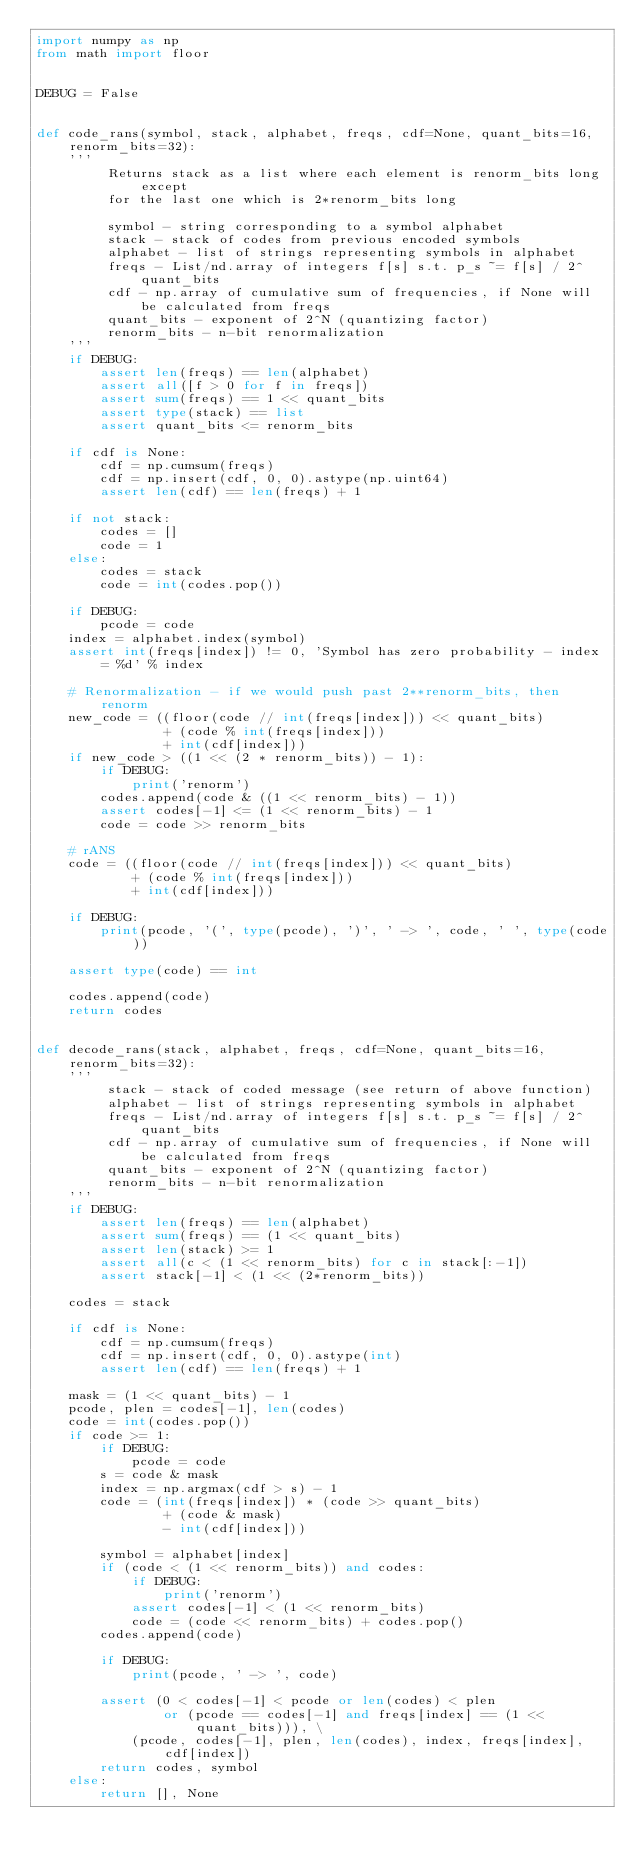<code> <loc_0><loc_0><loc_500><loc_500><_Python_>import numpy as np
from math import floor


DEBUG = False


def code_rans(symbol, stack, alphabet, freqs, cdf=None, quant_bits=16, renorm_bits=32):
    '''
         Returns stack as a list where each element is renorm_bits long except
         for the last one which is 2*renorm_bits long

         symbol - string corresponding to a symbol alphabet
         stack - stack of codes from previous encoded symbols
         alphabet - list of strings representing symbols in alphabet
         freqs - List/nd.array of integers f[s] s.t. p_s ~= f[s] / 2^quant_bits
         cdf - np.array of cumulative sum of frequencies, if None will be calculated from freqs
         quant_bits - exponent of 2^N (quantizing factor)
         renorm_bits - n-bit renormalization
    '''
    if DEBUG:
        assert len(freqs) == len(alphabet)
        assert all([f > 0 for f in freqs])
        assert sum(freqs) == 1 << quant_bits
        assert type(stack) == list
        assert quant_bits <= renorm_bits

    if cdf is None:
        cdf = np.cumsum(freqs)
        cdf = np.insert(cdf, 0, 0).astype(np.uint64)
        assert len(cdf) == len(freqs) + 1

    if not stack:
        codes = []
        code = 1
    else:
        codes = stack
        code = int(codes.pop())

    if DEBUG:
        pcode = code
    index = alphabet.index(symbol)
    assert int(freqs[index]) != 0, 'Symbol has zero probability - index = %d' % index

    # Renormalization - if we would push past 2**renorm_bits, then renorm
    new_code = ((floor(code // int(freqs[index])) << quant_bits)
                + (code % int(freqs[index]))
                + int(cdf[index]))
    if new_code > ((1 << (2 * renorm_bits)) - 1):
        if DEBUG:
            print('renorm')
        codes.append(code & ((1 << renorm_bits) - 1))
        assert codes[-1] <= (1 << renorm_bits) - 1
        code = code >> renorm_bits

    # rANS
    code = ((floor(code // int(freqs[index])) << quant_bits)
            + (code % int(freqs[index]))
            + int(cdf[index]))

    if DEBUG:
        print(pcode, '(', type(pcode), ')', ' -> ', code, ' ', type(code))

    assert type(code) == int

    codes.append(code)
    return codes


def decode_rans(stack, alphabet, freqs, cdf=None, quant_bits=16, renorm_bits=32):
    '''
         stack - stack of coded message (see return of above function)
         alphabet - list of strings representing symbols in alphabet
         freqs - List/nd.array of integers f[s] s.t. p_s ~= f[s] / 2^quant_bits
         cdf - np.array of cumulative sum of frequencies, if None will be calculated from freqs
         quant_bits - exponent of 2^N (quantizing factor)
         renorm_bits - n-bit renormalization
    '''
    if DEBUG:
        assert len(freqs) == len(alphabet)
        assert sum(freqs) == (1 << quant_bits)
        assert len(stack) >= 1
        assert all(c < (1 << renorm_bits) for c in stack[:-1])
        assert stack[-1] < (1 << (2*renorm_bits))

    codes = stack

    if cdf is None:
        cdf = np.cumsum(freqs)
        cdf = np.insert(cdf, 0, 0).astype(int)
        assert len(cdf) == len(freqs) + 1

    mask = (1 << quant_bits) - 1
    pcode, plen = codes[-1], len(codes)
    code = int(codes.pop())
    if code >= 1:
        if DEBUG:
            pcode = code
        s = code & mask
        index = np.argmax(cdf > s) - 1
        code = (int(freqs[index]) * (code >> quant_bits)
                + (code & mask)
                - int(cdf[index]))

        symbol = alphabet[index]
        if (code < (1 << renorm_bits)) and codes:
            if DEBUG:
                print('renorm')
            assert codes[-1] < (1 << renorm_bits)
            code = (code << renorm_bits) + codes.pop()
        codes.append(code)

        if DEBUG:
            print(pcode, ' -> ', code)

        assert (0 < codes[-1] < pcode or len(codes) < plen
                or (pcode == codes[-1] and freqs[index] == (1 << quant_bits))), \
            (pcode, codes[-1], plen, len(codes), index, freqs[index], cdf[index])
        return codes, symbol
    else:
        return [], None
</code> 